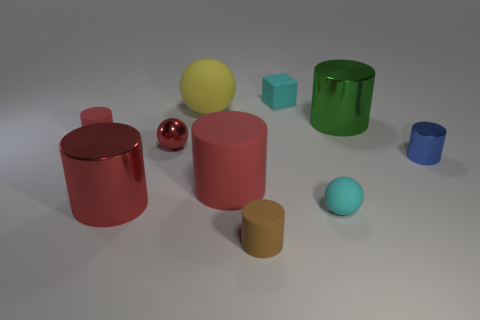How many red cylinders must be subtracted to get 1 red cylinders? 2 Subtract all yellow balls. How many red cylinders are left? 3 Subtract all small rubber spheres. How many spheres are left? 2 Subtract 1 balls. How many balls are left? 2 Subtract all green cylinders. How many cylinders are left? 5 Subtract all spheres. How many objects are left? 7 Subtract 1 brown cylinders. How many objects are left? 9 Subtract all gray spheres. Subtract all cyan cubes. How many spheres are left? 3 Subtract all big green matte spheres. Subtract all big red shiny cylinders. How many objects are left? 9 Add 7 cyan rubber objects. How many cyan rubber objects are left? 9 